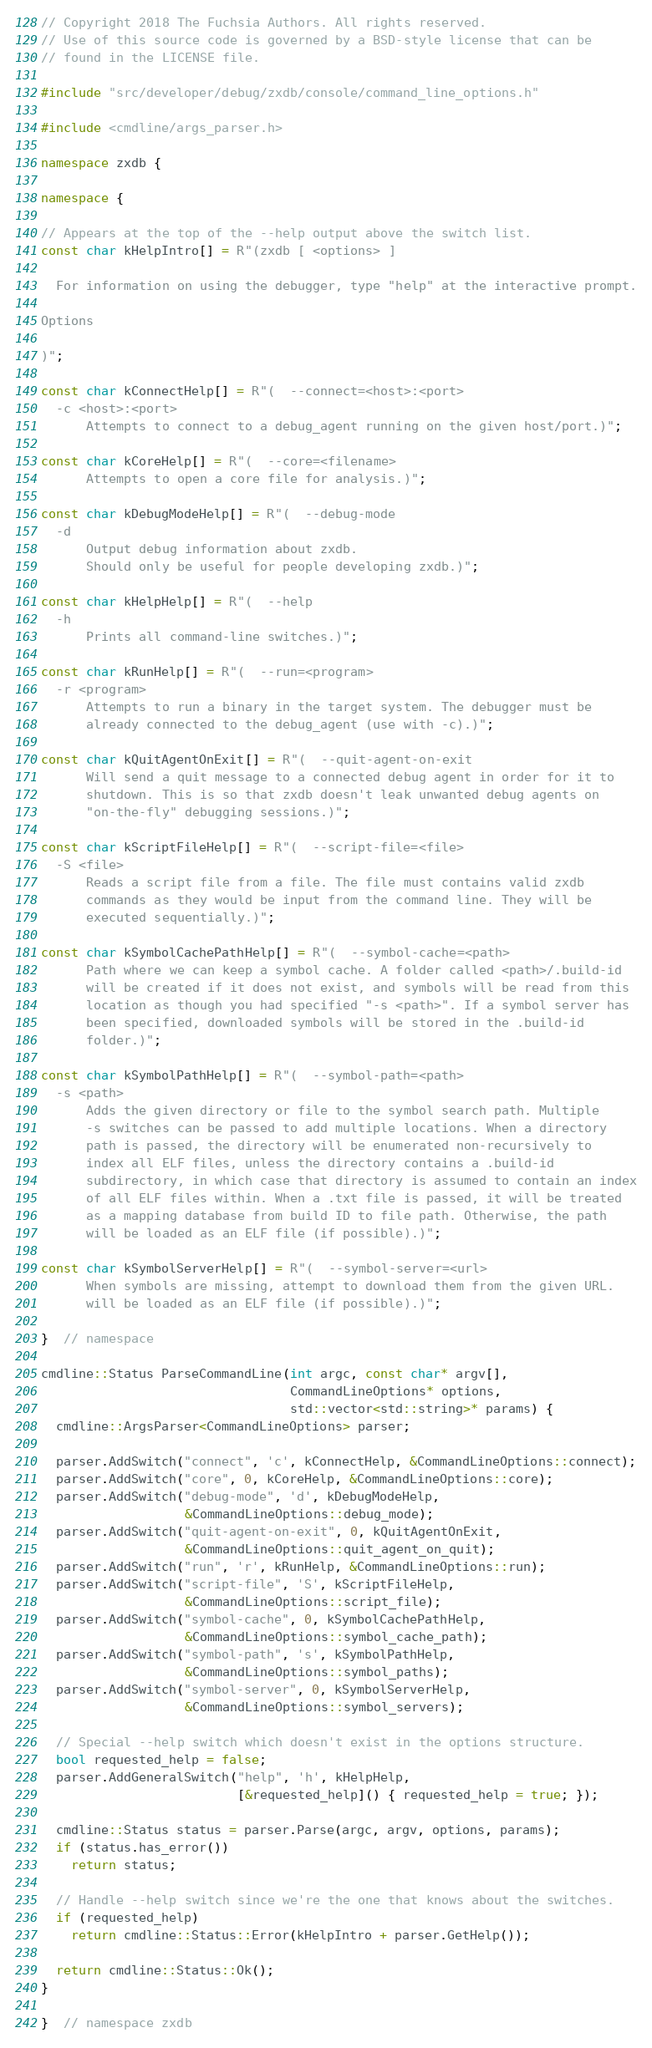<code> <loc_0><loc_0><loc_500><loc_500><_C++_>// Copyright 2018 The Fuchsia Authors. All rights reserved.
// Use of this source code is governed by a BSD-style license that can be
// found in the LICENSE file.

#include "src/developer/debug/zxdb/console/command_line_options.h"

#include <cmdline/args_parser.h>

namespace zxdb {

namespace {

// Appears at the top of the --help output above the switch list.
const char kHelpIntro[] = R"(zxdb [ <options> ]

  For information on using the debugger, type "help" at the interactive prompt.

Options

)";

const char kConnectHelp[] = R"(  --connect=<host>:<port>
  -c <host>:<port>
      Attempts to connect to a debug_agent running on the given host/port.)";

const char kCoreHelp[] = R"(  --core=<filename>
      Attempts to open a core file for analysis.)";

const char kDebugModeHelp[] = R"(  --debug-mode
  -d
      Output debug information about zxdb.
      Should only be useful for people developing zxdb.)";

const char kHelpHelp[] = R"(  --help
  -h
      Prints all command-line switches.)";

const char kRunHelp[] = R"(  --run=<program>
  -r <program>
      Attempts to run a binary in the target system. The debugger must be
      already connected to the debug_agent (use with -c).)";

const char kQuitAgentOnExit[] = R"(  --quit-agent-on-exit
      Will send a quit message to a connected debug agent in order for it to
      shutdown. This is so that zxdb doesn't leak unwanted debug agents on
      "on-the-fly" debugging sessions.)";

const char kScriptFileHelp[] = R"(  --script-file=<file>
  -S <file>
      Reads a script file from a file. The file must contains valid zxdb
      commands as they would be input from the command line. They will be
      executed sequentially.)";

const char kSymbolCachePathHelp[] = R"(  --symbol-cache=<path>
      Path where we can keep a symbol cache. A folder called <path>/.build-id
      will be created if it does not exist, and symbols will be read from this
      location as though you had specified "-s <path>". If a symbol server has
      been specified, downloaded symbols will be stored in the .build-id
      folder.)";

const char kSymbolPathHelp[] = R"(  --symbol-path=<path>
  -s <path>
      Adds the given directory or file to the symbol search path. Multiple
      -s switches can be passed to add multiple locations. When a directory
      path is passed, the directory will be enumerated non-recursively to
      index all ELF files, unless the directory contains a .build-id
      subdirectory, in which case that directory is assumed to contain an index
      of all ELF files within. When a .txt file is passed, it will be treated
      as a mapping database from build ID to file path. Otherwise, the path
      will be loaded as an ELF file (if possible).)";

const char kSymbolServerHelp[] = R"(  --symbol-server=<url>
      When symbols are missing, attempt to download them from the given URL.
      will be loaded as an ELF file (if possible).)";

}  // namespace

cmdline::Status ParseCommandLine(int argc, const char* argv[],
                                 CommandLineOptions* options,
                                 std::vector<std::string>* params) {
  cmdline::ArgsParser<CommandLineOptions> parser;

  parser.AddSwitch("connect", 'c', kConnectHelp, &CommandLineOptions::connect);
  parser.AddSwitch("core", 0, kCoreHelp, &CommandLineOptions::core);
  parser.AddSwitch("debug-mode", 'd', kDebugModeHelp,
                   &CommandLineOptions::debug_mode);
  parser.AddSwitch("quit-agent-on-exit", 0, kQuitAgentOnExit,
                   &CommandLineOptions::quit_agent_on_quit);
  parser.AddSwitch("run", 'r', kRunHelp, &CommandLineOptions::run);
  parser.AddSwitch("script-file", 'S', kScriptFileHelp,
                   &CommandLineOptions::script_file);
  parser.AddSwitch("symbol-cache", 0, kSymbolCachePathHelp,
                   &CommandLineOptions::symbol_cache_path);
  parser.AddSwitch("symbol-path", 's', kSymbolPathHelp,
                   &CommandLineOptions::symbol_paths);
  parser.AddSwitch("symbol-server", 0, kSymbolServerHelp,
                   &CommandLineOptions::symbol_servers);

  // Special --help switch which doesn't exist in the options structure.
  bool requested_help = false;
  parser.AddGeneralSwitch("help", 'h', kHelpHelp,
                          [&requested_help]() { requested_help = true; });

  cmdline::Status status = parser.Parse(argc, argv, options, params);
  if (status.has_error())
    return status;

  // Handle --help switch since we're the one that knows about the switches.
  if (requested_help)
    return cmdline::Status::Error(kHelpIntro + parser.GetHelp());

  return cmdline::Status::Ok();
}

}  // namespace zxdb
</code> 